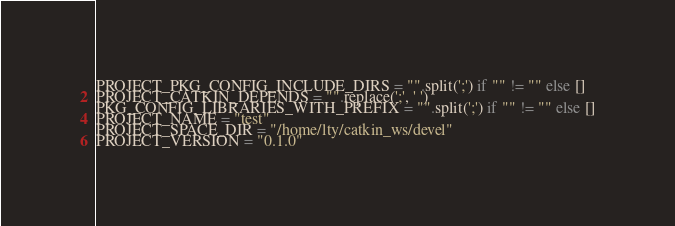Convert code to text. <code><loc_0><loc_0><loc_500><loc_500><_Python_>PROJECT_PKG_CONFIG_INCLUDE_DIRS = "".split(';') if "" != "" else []
PROJECT_CATKIN_DEPENDS = "".replace(';', ' ')
PKG_CONFIG_LIBRARIES_WITH_PREFIX = "".split(';') if "" != "" else []
PROJECT_NAME = "test"
PROJECT_SPACE_DIR = "/home/lty/catkin_ws/devel"
PROJECT_VERSION = "0.1.0"
</code> 